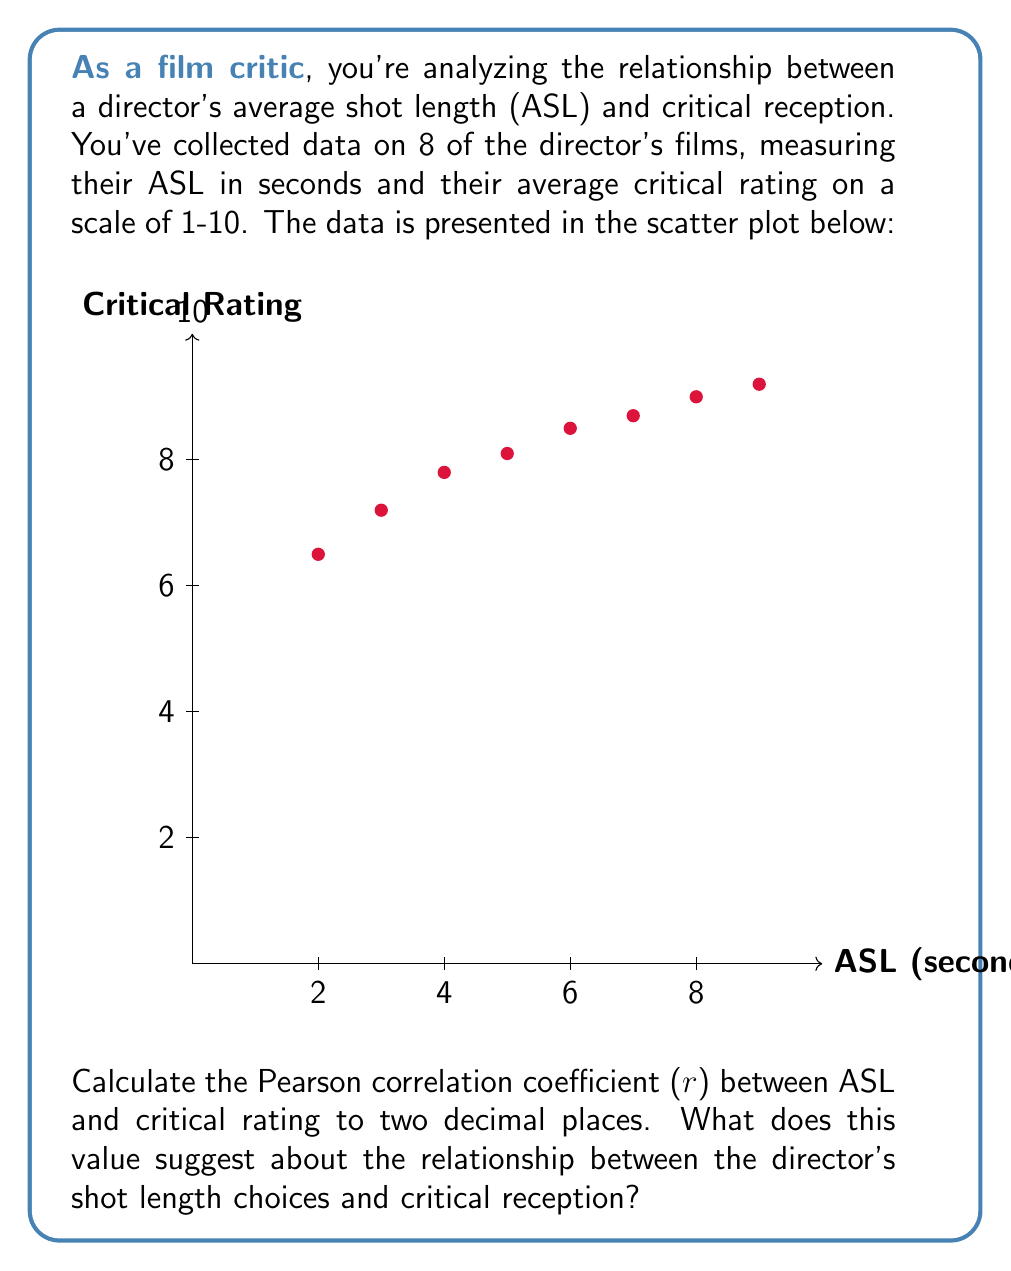Can you answer this question? To calculate the Pearson correlation coefficient (r), we'll use the formula:

$$ r = \frac{\sum_{i=1}^{n} (x_i - \bar{x})(y_i - \bar{y})}{\sqrt{\sum_{i=1}^{n} (x_i - \bar{x})^2 \sum_{i=1}^{n} (y_i - \bar{y})^2}} $$

Where:
$x_i$ = ASL values
$y_i$ = Critical rating values
$\bar{x}$ = Mean of ASL values
$\bar{y}$ = Mean of critical rating values
$n$ = Number of data points (8)

Step 1: Calculate means
$\bar{x} = (2+3+4+5+6+7+8+9) / 8 = 5.5$
$\bar{y} = (6.5+7.2+7.8+8.1+8.5+8.7+9.0+9.2) / 8 = 8.125$

Step 2: Calculate $(x_i - \bar{x})$, $(y_i - \bar{y})$, $(x_i - \bar{x})^2$, $(y_i - \bar{y})^2$, and $(x_i - \bar{x})(y_i - \bar{y})$ for each data point.

Step 3: Sum the results:
$\sum (x_i - \bar{x})(y_i - \bar{y}) = 11.325$
$\sum (x_i - \bar{x})^2 = 60$
$\sum (y_i - \bar{y})^2 = 4.96875$

Step 4: Apply the formula:

$$ r = \frac{11.325}{\sqrt{60 * 4.96875}} = 0.9279 $$

Step 5: Round to two decimal places: r = 0.93

This strong positive correlation (close to 1) suggests that as the director's average shot length increases, the critical reception tends to improve significantly. This relationship indicates that the director's use of longer shots is generally associated with more favorable critical reviews.
Answer: r = 0.93; Strong positive correlation between ASL and critical rating 